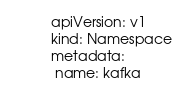<code> <loc_0><loc_0><loc_500><loc_500><_YAML_>apiVersion: v1
kind: Namespace
metadata:
 name: kafka</code> 